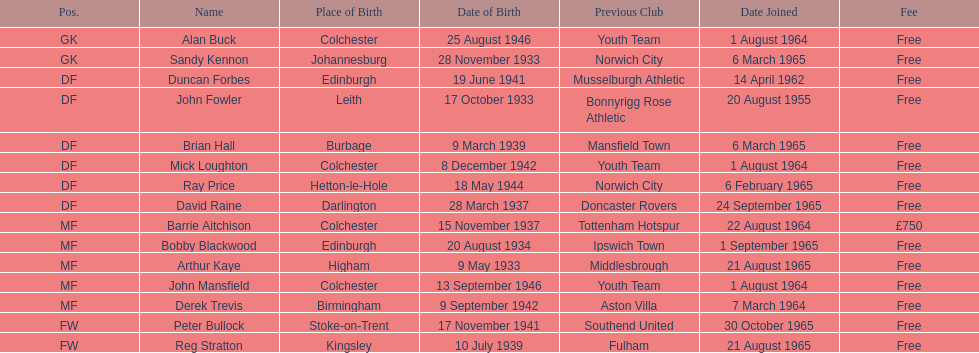How many players have the designation of df? 6. 